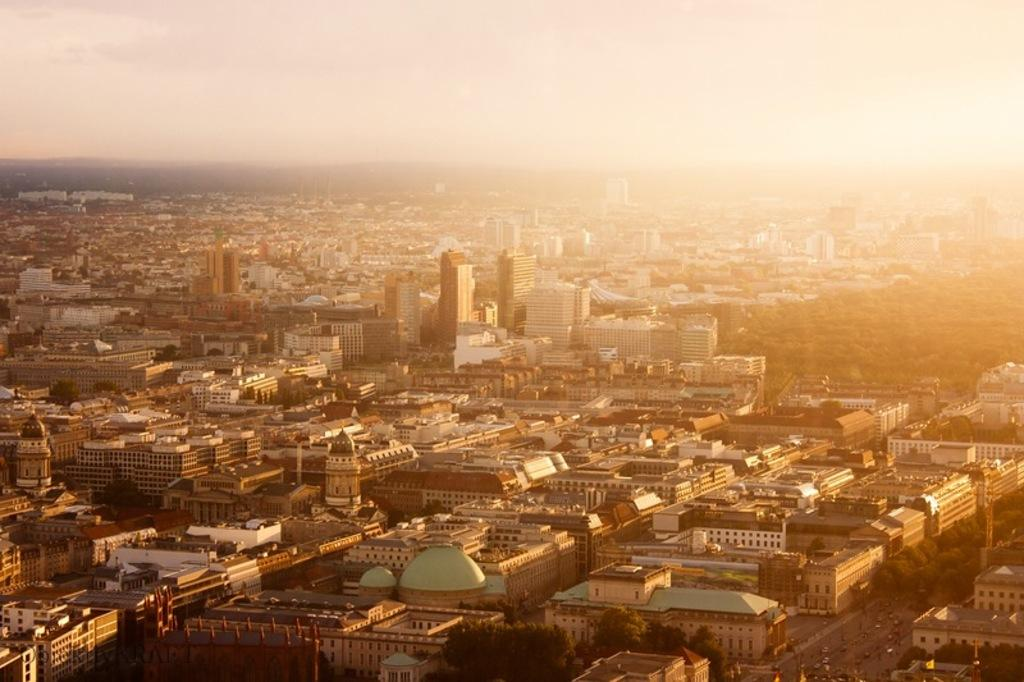What type of structures can be seen in the image? There are buildings in the image. What other natural elements are present in the image? There are trees in the image. What mode of transportation can be observed in the image? Cars are moving on the road in the image. What holiday is being celebrated in the image? There is no indication of a holiday being celebrated in the image. Who is the expert in the image? There is no expert present in the image. 